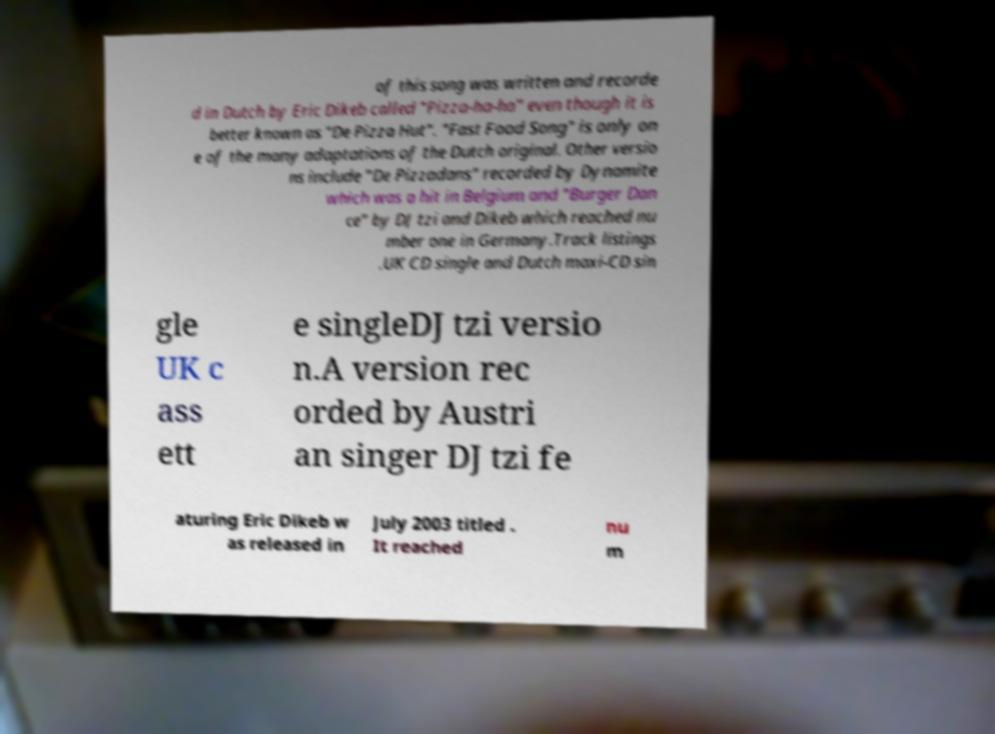I need the written content from this picture converted into text. Can you do that? of this song was written and recorde d in Dutch by Eric Dikeb called "Pizza-ha-ha" even though it is better known as "De Pizza Hut". "Fast Food Song" is only on e of the many adaptations of the Dutch original. Other versio ns include "De Pizzadans" recorded by Dynamite which was a hit in Belgium and "Burger Dan ce" by DJ tzi and Dikeb which reached nu mber one in Germany.Track listings .UK CD single and Dutch maxi-CD sin gle UK c ass ett e singleDJ tzi versio n.A version rec orded by Austri an singer DJ tzi fe aturing Eric Dikeb w as released in July 2003 titled . It reached nu m 